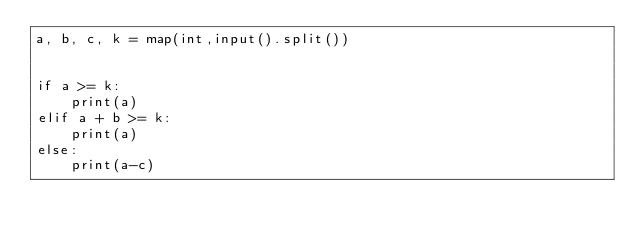Convert code to text. <code><loc_0><loc_0><loc_500><loc_500><_Python_>a, b, c, k = map(int,input().split())


if a >= k:
    print(a)
elif a + b >= k:
    print(a)
else:
    print(a-c)</code> 